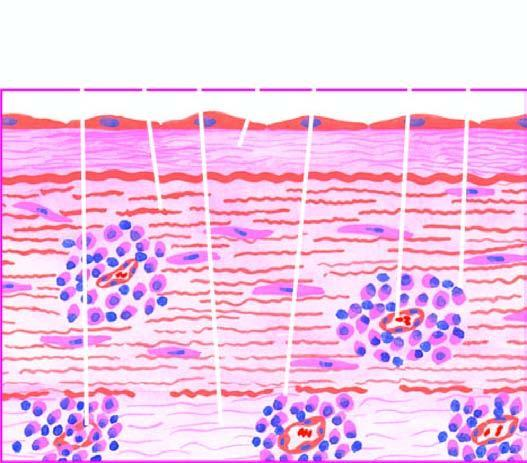s section from margin of amoebic ulcer perivascular infiltrate of plasma cells, lymphocytes and macrophages?
Answer the question using a single word or phrase. No 